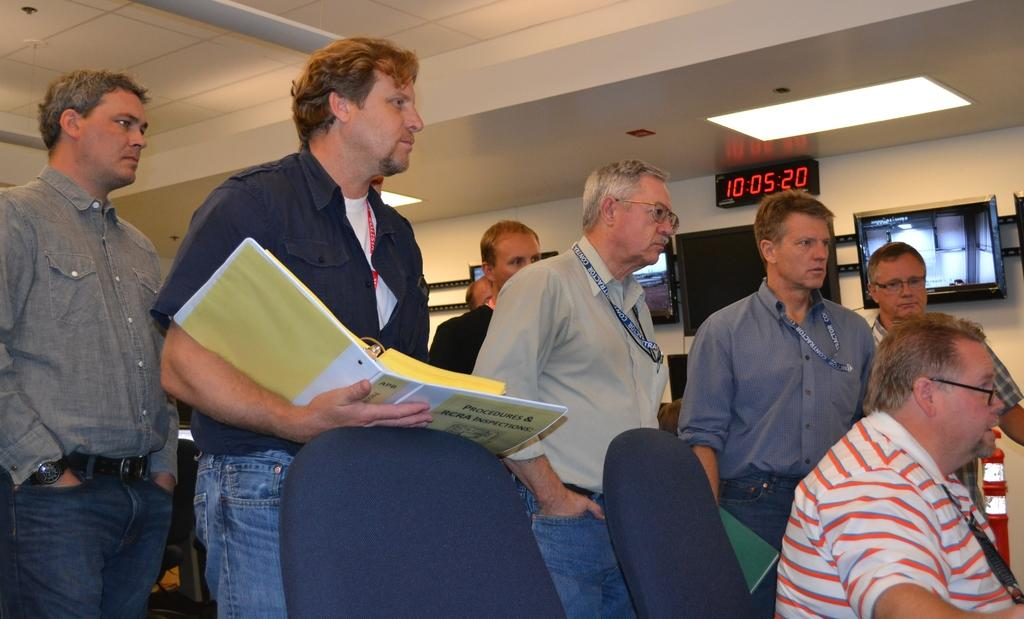What is the main activity of the people in the image? There is a group of people standing in the image, but their activity is not specified. What is the position of the man in the image? There is a man sitting on a chair in the image. What items can be seen related to reading or learning? There are books visible in the image. What electronic devices are present in the background of the image? There are televisions in the background of the image. What type of lighting is present in the background of the image? There are lights in the background of the image. What type of structure is visible in the background of the image? There is a wall in the background of the image. Where is the kettle located in the image? There is no kettle present in the image. What type of bait is being used by the people in the image? There is no indication of fishing or bait in the image. What is the purpose of the hydrant in the image? There is no hydrant present in the image. 